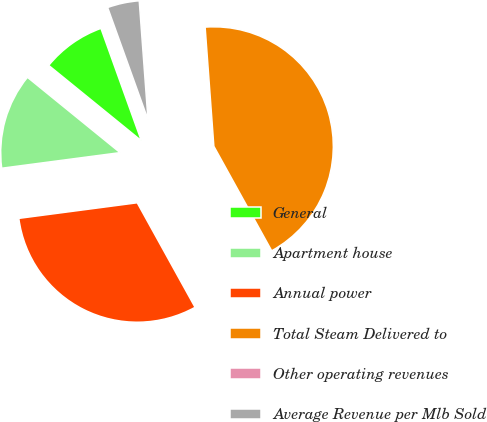Convert chart to OTSL. <chart><loc_0><loc_0><loc_500><loc_500><pie_chart><fcel>General<fcel>Apartment house<fcel>Annual power<fcel>Total Steam Delivered to<fcel>Other operating revenues<fcel>Average Revenue per Mlb Sold<nl><fcel>8.64%<fcel>12.95%<fcel>30.96%<fcel>43.12%<fcel>0.01%<fcel>4.32%<nl></chart> 